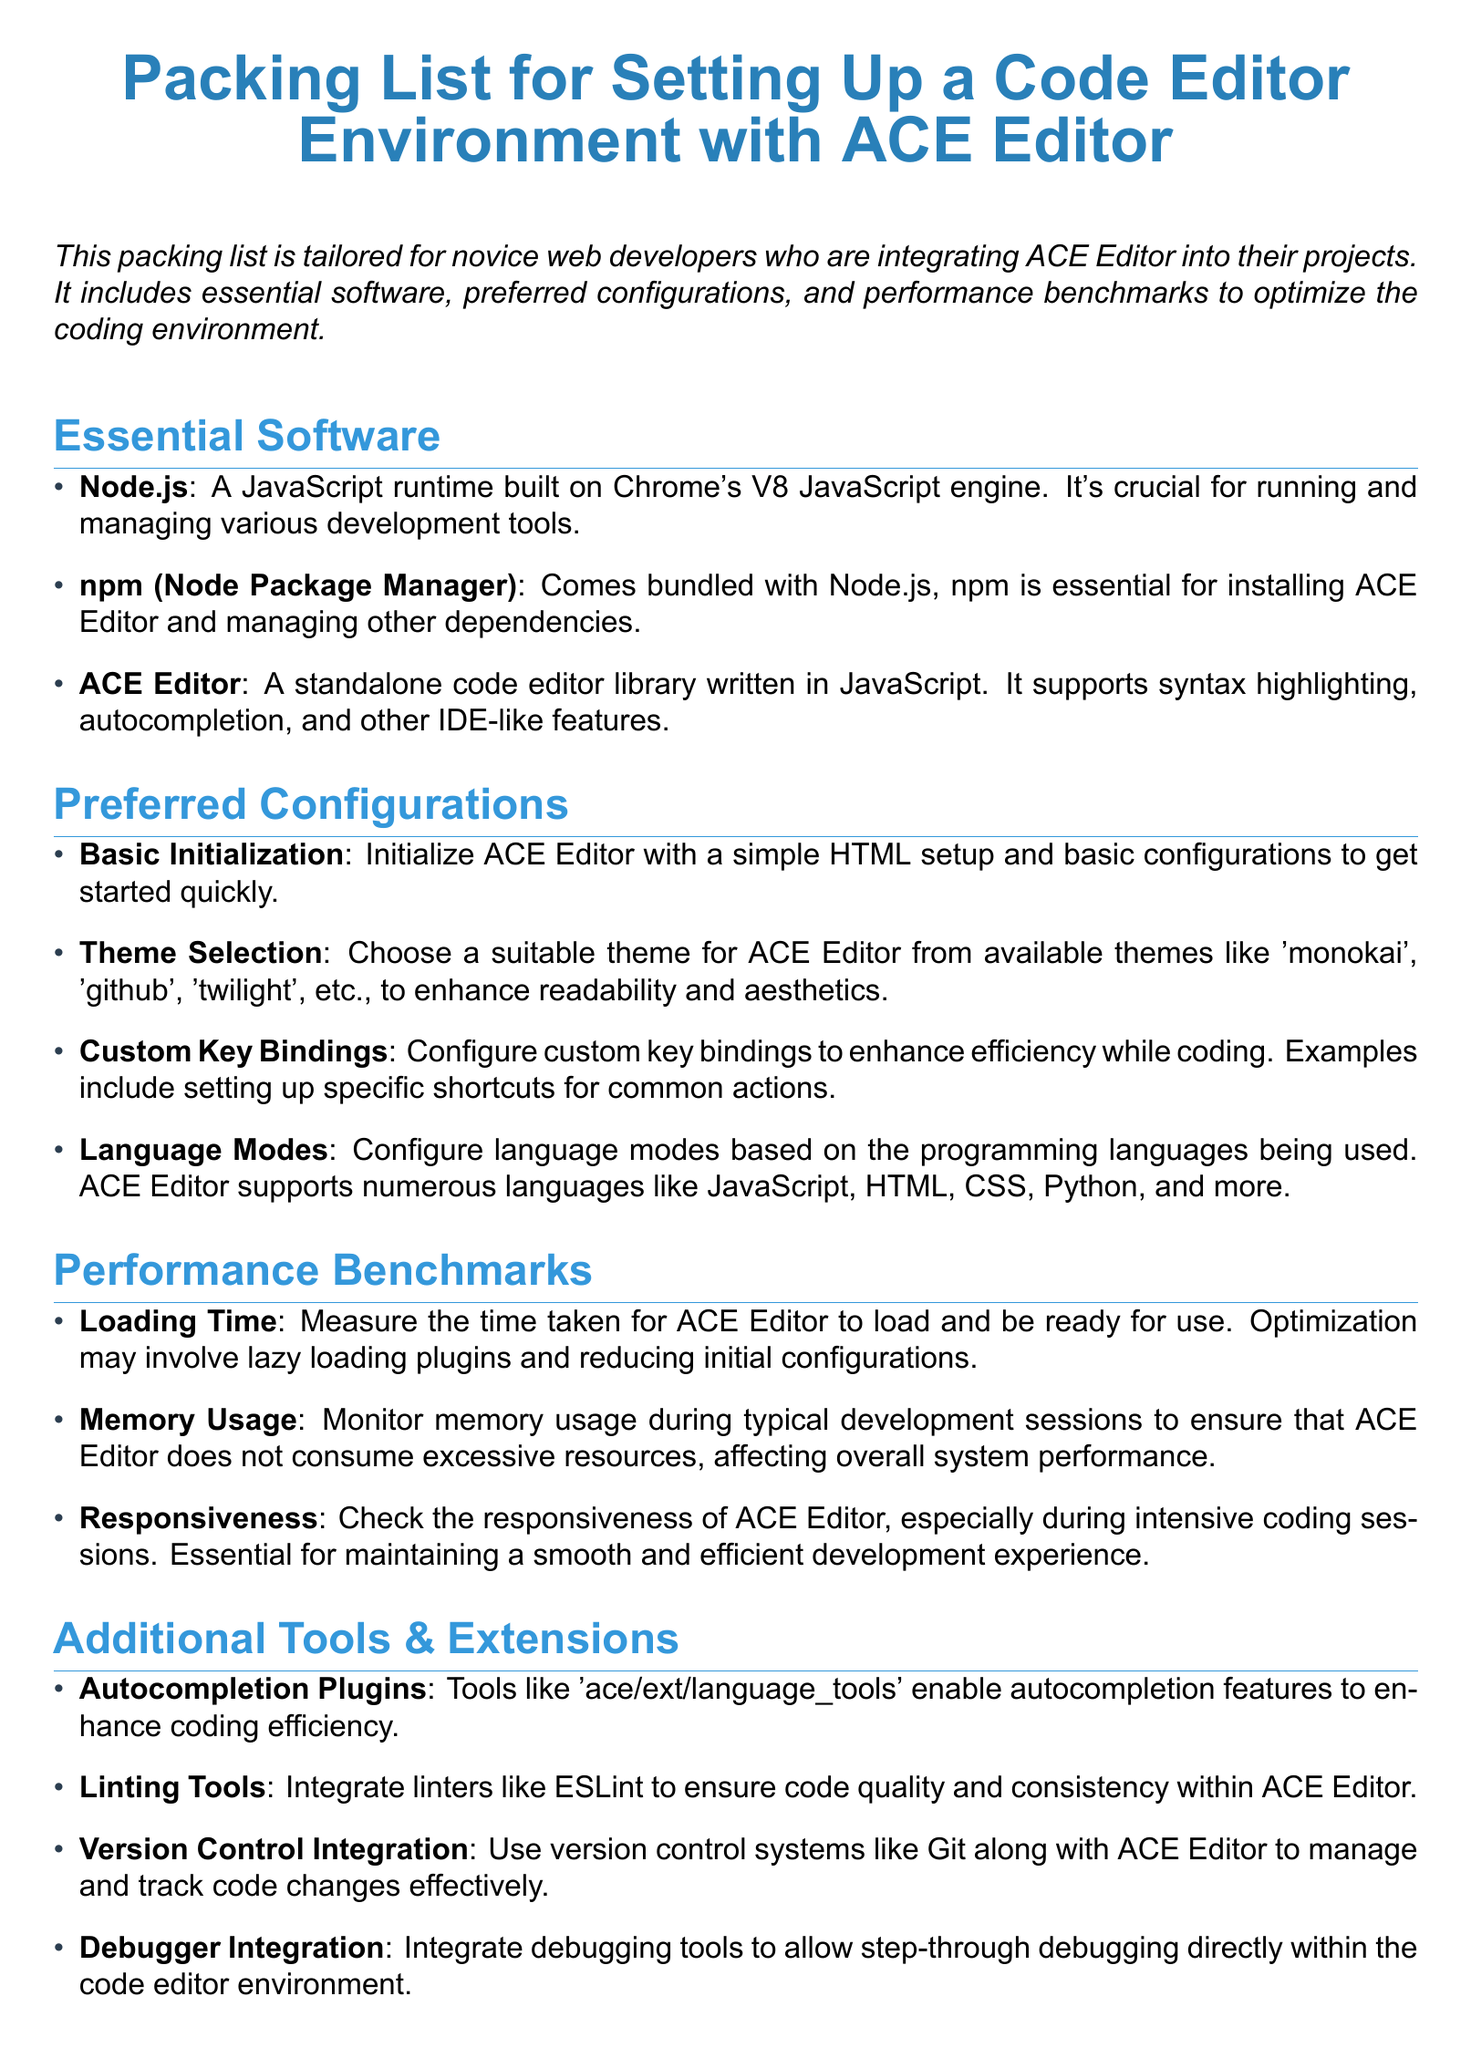What is the main title of the document? The title is "Packing List for Setting Up a Code Editor Environment with ACE Editor."
Answer: Packing List for Setting Up a Code Editor Environment with ACE Editor Which JavaScript runtime is mentioned as essential software? The software mentioned is Node.js, which is crucial for managing development tools.
Answer: Node.js What is the purpose of npm in the document? Npm, bundled with Node.js, is essential for installing ACE Editor and managing dependencies.
Answer: Installing ACE Editor Name one of the language modes supported by ACE Editor. The document lists languages supported by ACE Editor, such as JavaScript, HTML, or CSS.
Answer: JavaScript What should be monitored to ensure ACE Editor does not consume excessive resources? The document mentions monitoring memory usage to check resource consumption.
Answer: Memory Usage Which plugin is suggested for enhancing coding efficiency? The document recommends using autocompletion plugins like 'ace/ext/language_tools'.
Answer: Autocompletion Plugins What is an example of a preferred theme for ACE Editor? The document mentions available themes, such as 'monokai', 'github', or 'twilight'.
Answer: monokai What is the key focus of performance benchmarks mentioned? The performance benchmarks focus on aspects like loading time, memory usage, and responsiveness.
Answer: Loading Time Which version control system is mentioned for managing code changes? The document suggests using Git for version control integration alongside ACE Editor.
Answer: Git 